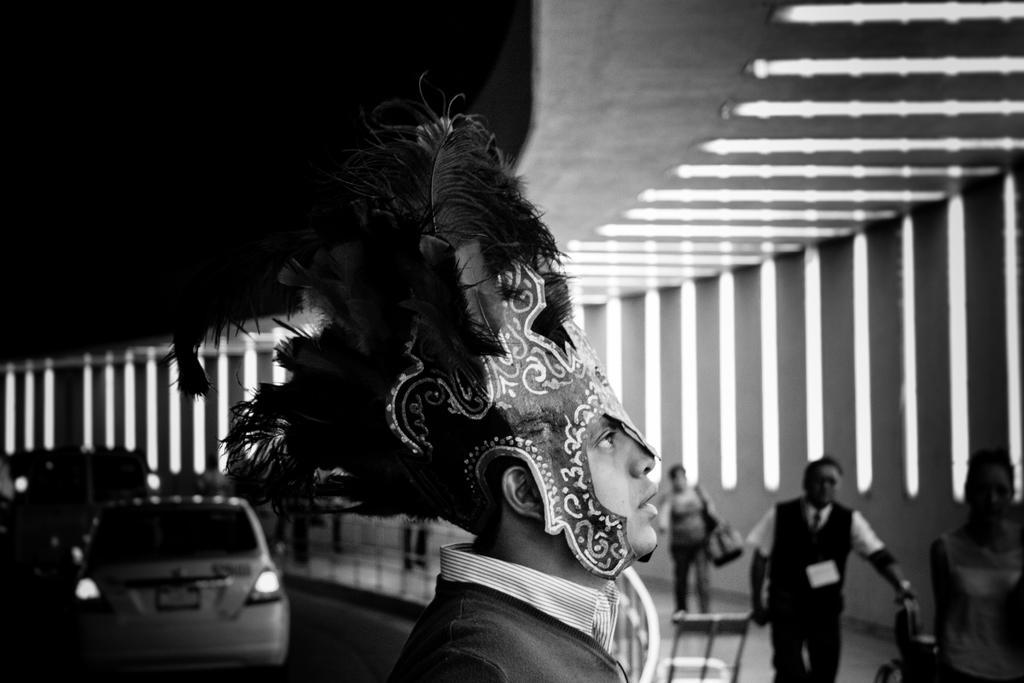Please provide a concise description of this image. This is a black and white picture. On the right side of the picture we can see people. On the left side we can see vehicles. We can see a person wearing a fancy cap and a mask. 